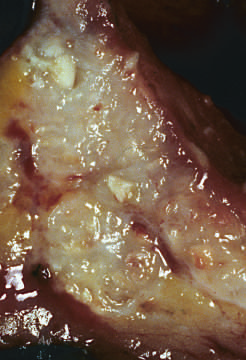where are areas of chalky necrosis present?
Answer the question using a single word or phrase. Within the colon wall 